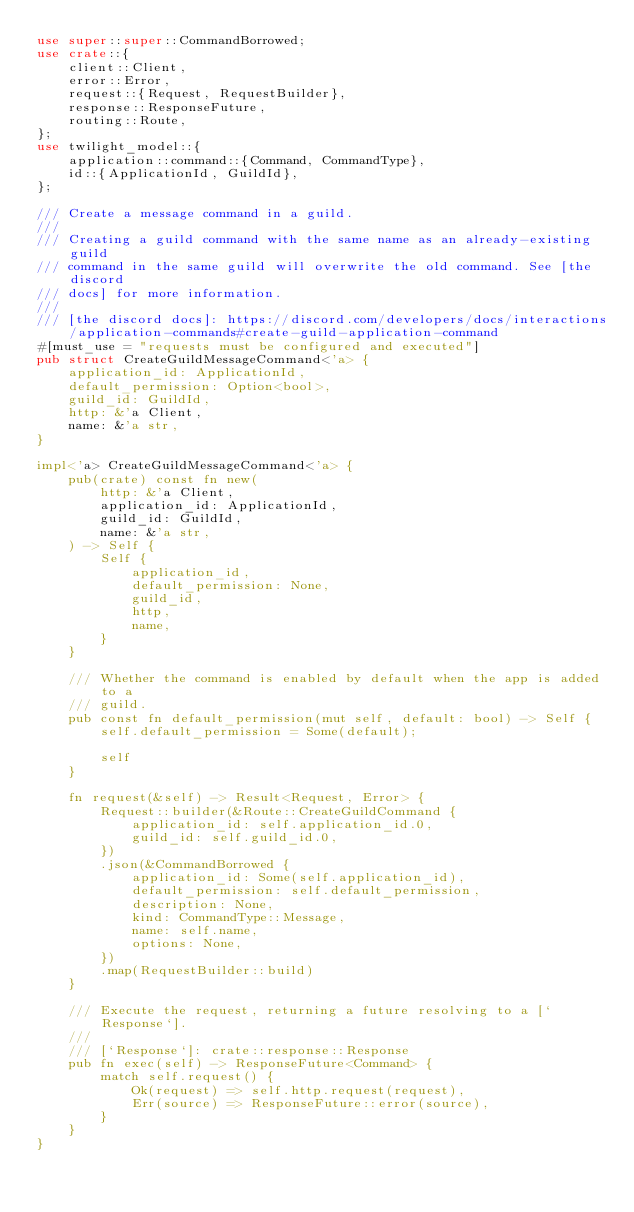<code> <loc_0><loc_0><loc_500><loc_500><_Rust_>use super::super::CommandBorrowed;
use crate::{
    client::Client,
    error::Error,
    request::{Request, RequestBuilder},
    response::ResponseFuture,
    routing::Route,
};
use twilight_model::{
    application::command::{Command, CommandType},
    id::{ApplicationId, GuildId},
};

/// Create a message command in a guild.
///
/// Creating a guild command with the same name as an already-existing guild
/// command in the same guild will overwrite the old command. See [the discord
/// docs] for more information.
///
/// [the discord docs]: https://discord.com/developers/docs/interactions/application-commands#create-guild-application-command
#[must_use = "requests must be configured and executed"]
pub struct CreateGuildMessageCommand<'a> {
    application_id: ApplicationId,
    default_permission: Option<bool>,
    guild_id: GuildId,
    http: &'a Client,
    name: &'a str,
}

impl<'a> CreateGuildMessageCommand<'a> {
    pub(crate) const fn new(
        http: &'a Client,
        application_id: ApplicationId,
        guild_id: GuildId,
        name: &'a str,
    ) -> Self {
        Self {
            application_id,
            default_permission: None,
            guild_id,
            http,
            name,
        }
    }

    /// Whether the command is enabled by default when the app is added to a
    /// guild.
    pub const fn default_permission(mut self, default: bool) -> Self {
        self.default_permission = Some(default);

        self
    }

    fn request(&self) -> Result<Request, Error> {
        Request::builder(&Route::CreateGuildCommand {
            application_id: self.application_id.0,
            guild_id: self.guild_id.0,
        })
        .json(&CommandBorrowed {
            application_id: Some(self.application_id),
            default_permission: self.default_permission,
            description: None,
            kind: CommandType::Message,
            name: self.name,
            options: None,
        })
        .map(RequestBuilder::build)
    }

    /// Execute the request, returning a future resolving to a [`Response`].
    ///
    /// [`Response`]: crate::response::Response
    pub fn exec(self) -> ResponseFuture<Command> {
        match self.request() {
            Ok(request) => self.http.request(request),
            Err(source) => ResponseFuture::error(source),
        }
    }
}
</code> 